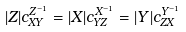Convert formula to latex. <formula><loc_0><loc_0><loc_500><loc_500>| Z | c ^ { Z ^ { - 1 } } _ { X Y } = | X | c ^ { X ^ { - 1 } } _ { Y Z } = | Y | c ^ { Y ^ { - 1 } } _ { Z X }</formula> 